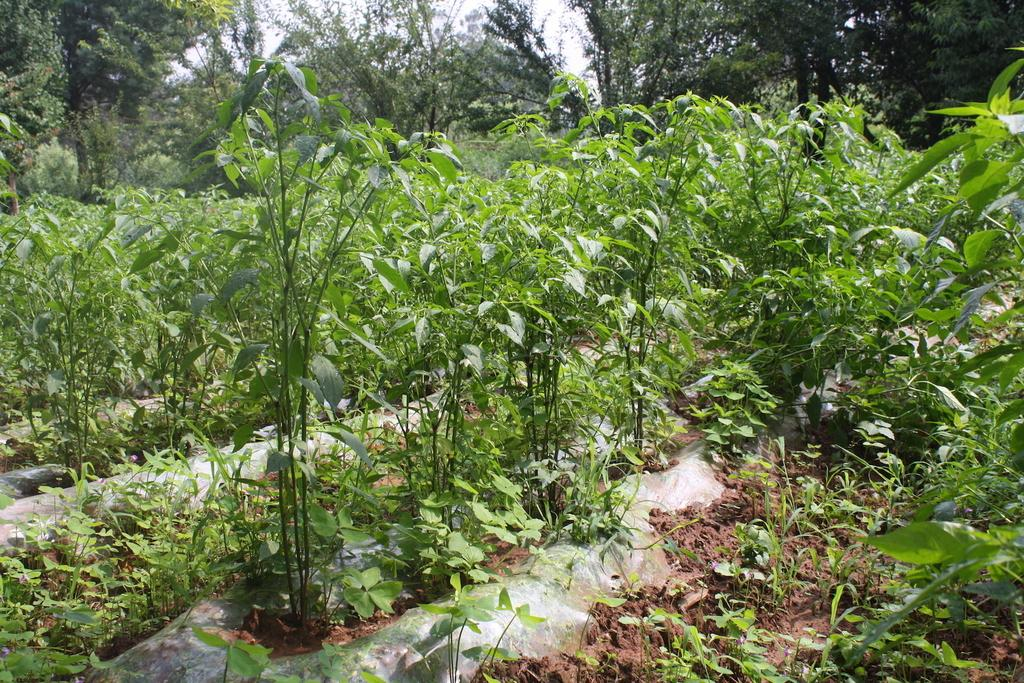What type of vegetation is present on the ground in the image? There are plants on the ground in the image. What can be seen in the distance in the image? There are trees visible in the background of the image. What is the health status of the board in the image? There is no board present in the image, so it is not possible to determine its health status. 